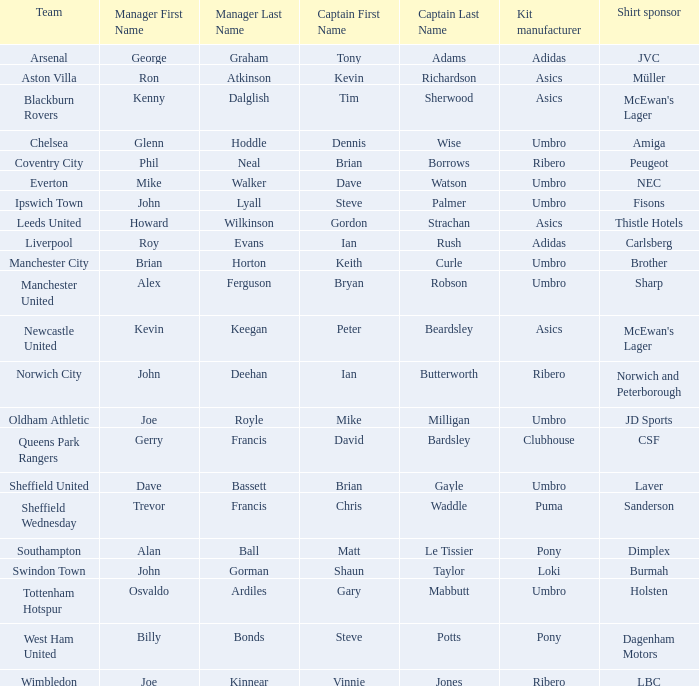Which manager has sheffield wednesday as the team? Trevor Francis. 